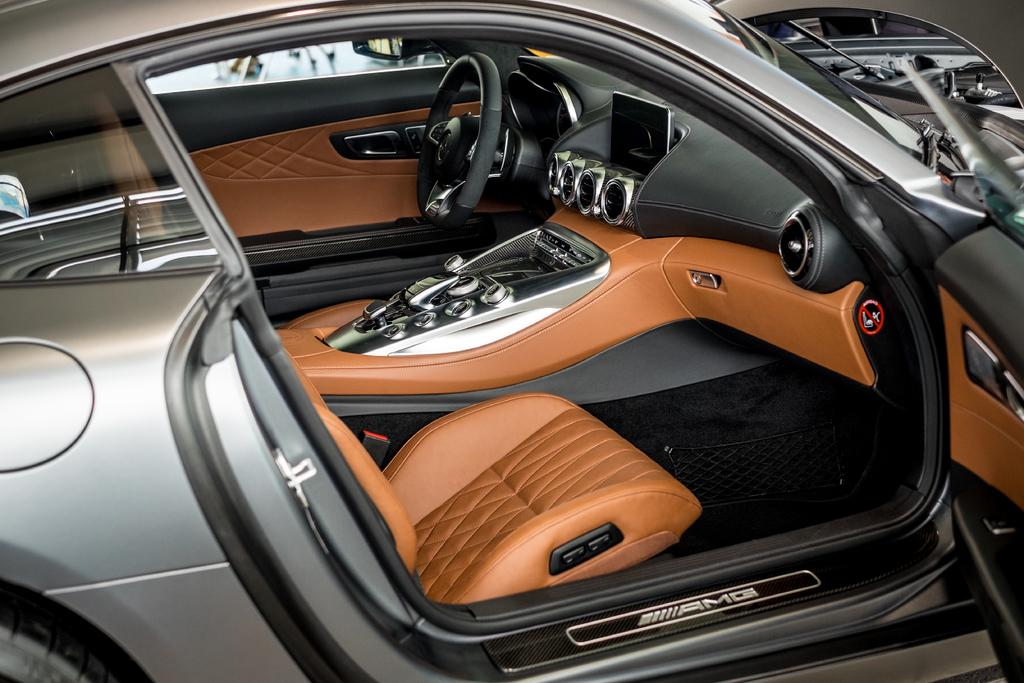What is the position of the car door in the image? The car door is opened in the image. What can be seen inside the car? The interior view of the car is visible. What is present behind the steering wheel? There is a dashboard in the image. What is the car equipped with for the driver to sit on? There is a seat in the image. Can you tell me how many goldfish are swimming in the car's channel in the image? There are no goldfish or channels present in the image; it only features the car's interior. 